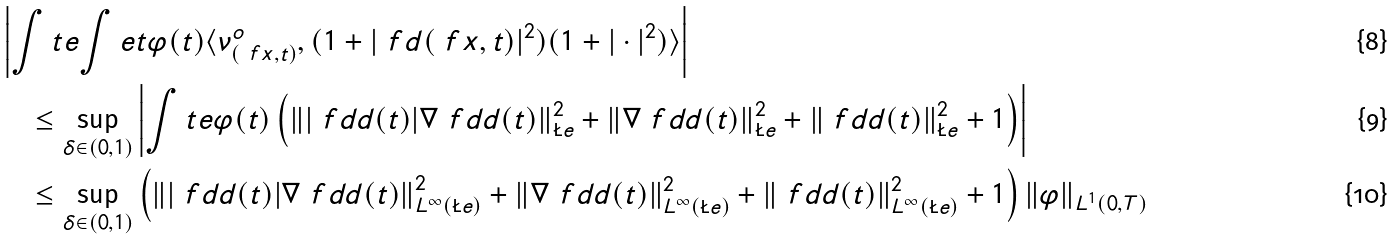<formula> <loc_0><loc_0><loc_500><loc_500>& \left | \int t e { \int e t { \varphi ( t ) \langle \nu _ { ( \ f x , t ) } ^ { o } , ( 1 + | \ f d ( \ f x , t ) | ^ { 2 } ) ( 1 + | \cdot | ^ { 2 } ) \rangle } } \right | \\ & \quad \leq \sup _ { \delta \in ( 0 , 1 ) } \left | \int t e { \varphi ( t ) \left ( \left \| | \ f d d ( t ) | \nabla \ f d d ( t ) \right \| _ { \L e } ^ { 2 } + \| \nabla \ f d d ( t ) \| _ { \L e } ^ { 2 } + \| \ f d d ( t ) \| _ { \L e } ^ { 2 } + 1 \right ) } \right | \\ & \quad \leq \sup _ { \delta \in ( 0 , 1 ) } \left ( \left \| | \ f d d ( t ) | \nabla \ f d d ( t ) \right \| _ { L ^ { \infty } ( \L e ) } ^ { 2 } + \| \nabla \ f d d ( t ) \| _ { L ^ { \infty } ( \L e ) } ^ { 2 } + \| \ f d d ( t ) \| _ { L ^ { \infty } ( \L e ) } ^ { 2 } + 1 \right ) \| \varphi \| _ { L ^ { 1 } ( 0 , T ) } \,</formula> 